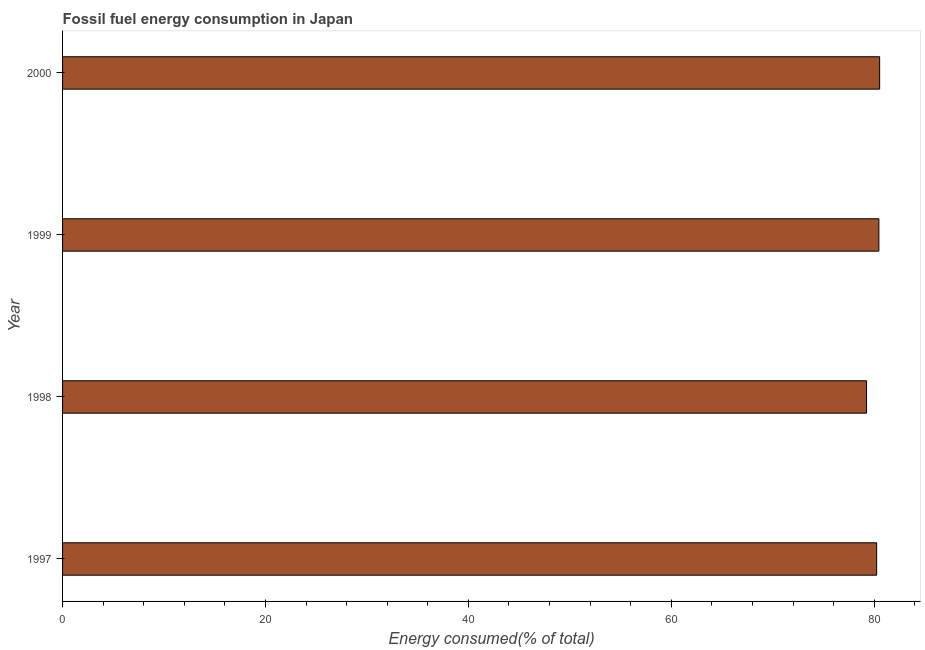Does the graph contain grids?
Give a very brief answer. No. What is the title of the graph?
Your response must be concise. Fossil fuel energy consumption in Japan. What is the label or title of the X-axis?
Make the answer very short. Energy consumed(% of total). What is the label or title of the Y-axis?
Provide a short and direct response. Year. What is the fossil fuel energy consumption in 1997?
Your response must be concise. 80.24. Across all years, what is the maximum fossil fuel energy consumption?
Make the answer very short. 80.54. Across all years, what is the minimum fossil fuel energy consumption?
Keep it short and to the point. 79.25. In which year was the fossil fuel energy consumption maximum?
Make the answer very short. 2000. What is the sum of the fossil fuel energy consumption?
Make the answer very short. 320.49. What is the difference between the fossil fuel energy consumption in 1997 and 1998?
Offer a very short reply. 1. What is the average fossil fuel energy consumption per year?
Provide a short and direct response. 80.12. What is the median fossil fuel energy consumption?
Ensure brevity in your answer.  80.35. In how many years, is the fossil fuel energy consumption greater than 20 %?
Keep it short and to the point. 4. Is the difference between the fossil fuel energy consumption in 1997 and 1998 greater than the difference between any two years?
Your answer should be compact. No. What is the difference between the highest and the second highest fossil fuel energy consumption?
Offer a terse response. 0.07. What is the difference between the highest and the lowest fossil fuel energy consumption?
Make the answer very short. 1.29. In how many years, is the fossil fuel energy consumption greater than the average fossil fuel energy consumption taken over all years?
Offer a very short reply. 3. How many bars are there?
Keep it short and to the point. 4. What is the Energy consumed(% of total) in 1997?
Provide a short and direct response. 80.24. What is the Energy consumed(% of total) in 1998?
Your response must be concise. 79.25. What is the Energy consumed(% of total) of 1999?
Keep it short and to the point. 80.46. What is the Energy consumed(% of total) in 2000?
Your answer should be very brief. 80.54. What is the difference between the Energy consumed(% of total) in 1997 and 1998?
Give a very brief answer. 1. What is the difference between the Energy consumed(% of total) in 1997 and 1999?
Your answer should be compact. -0.22. What is the difference between the Energy consumed(% of total) in 1997 and 2000?
Make the answer very short. -0.29. What is the difference between the Energy consumed(% of total) in 1998 and 1999?
Make the answer very short. -1.21. What is the difference between the Energy consumed(% of total) in 1998 and 2000?
Ensure brevity in your answer.  -1.29. What is the difference between the Energy consumed(% of total) in 1999 and 2000?
Your response must be concise. -0.08. What is the ratio of the Energy consumed(% of total) in 1997 to that in 1998?
Provide a short and direct response. 1.01. What is the ratio of the Energy consumed(% of total) in 1997 to that in 1999?
Provide a succinct answer. 1. 